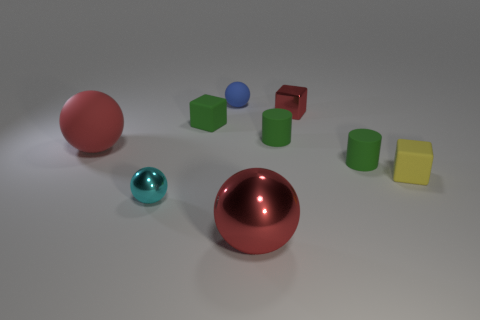Subtract 1 balls. How many balls are left? 3 Add 1 tiny yellow blocks. How many objects exist? 10 Subtract all balls. How many objects are left? 5 Subtract all tiny gray rubber things. Subtract all red shiny objects. How many objects are left? 7 Add 2 green things. How many green things are left? 5 Add 6 yellow rubber blocks. How many yellow rubber blocks exist? 7 Subtract 0 blue cubes. How many objects are left? 9 